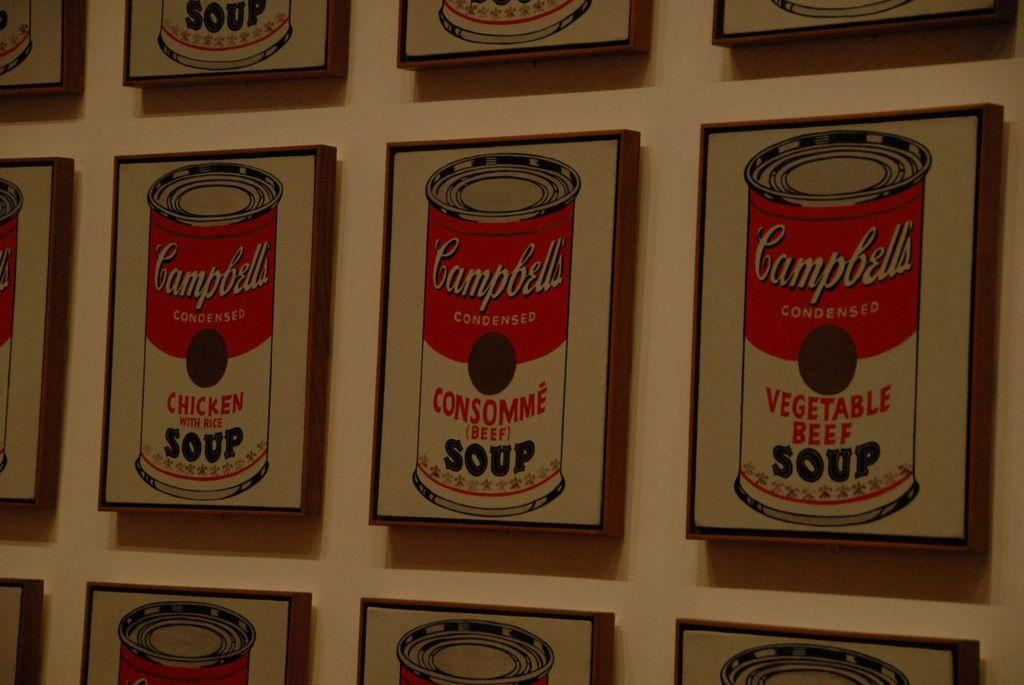<image>
Present a compact description of the photo's key features. A bunch of framed images of Campbell's soups. 